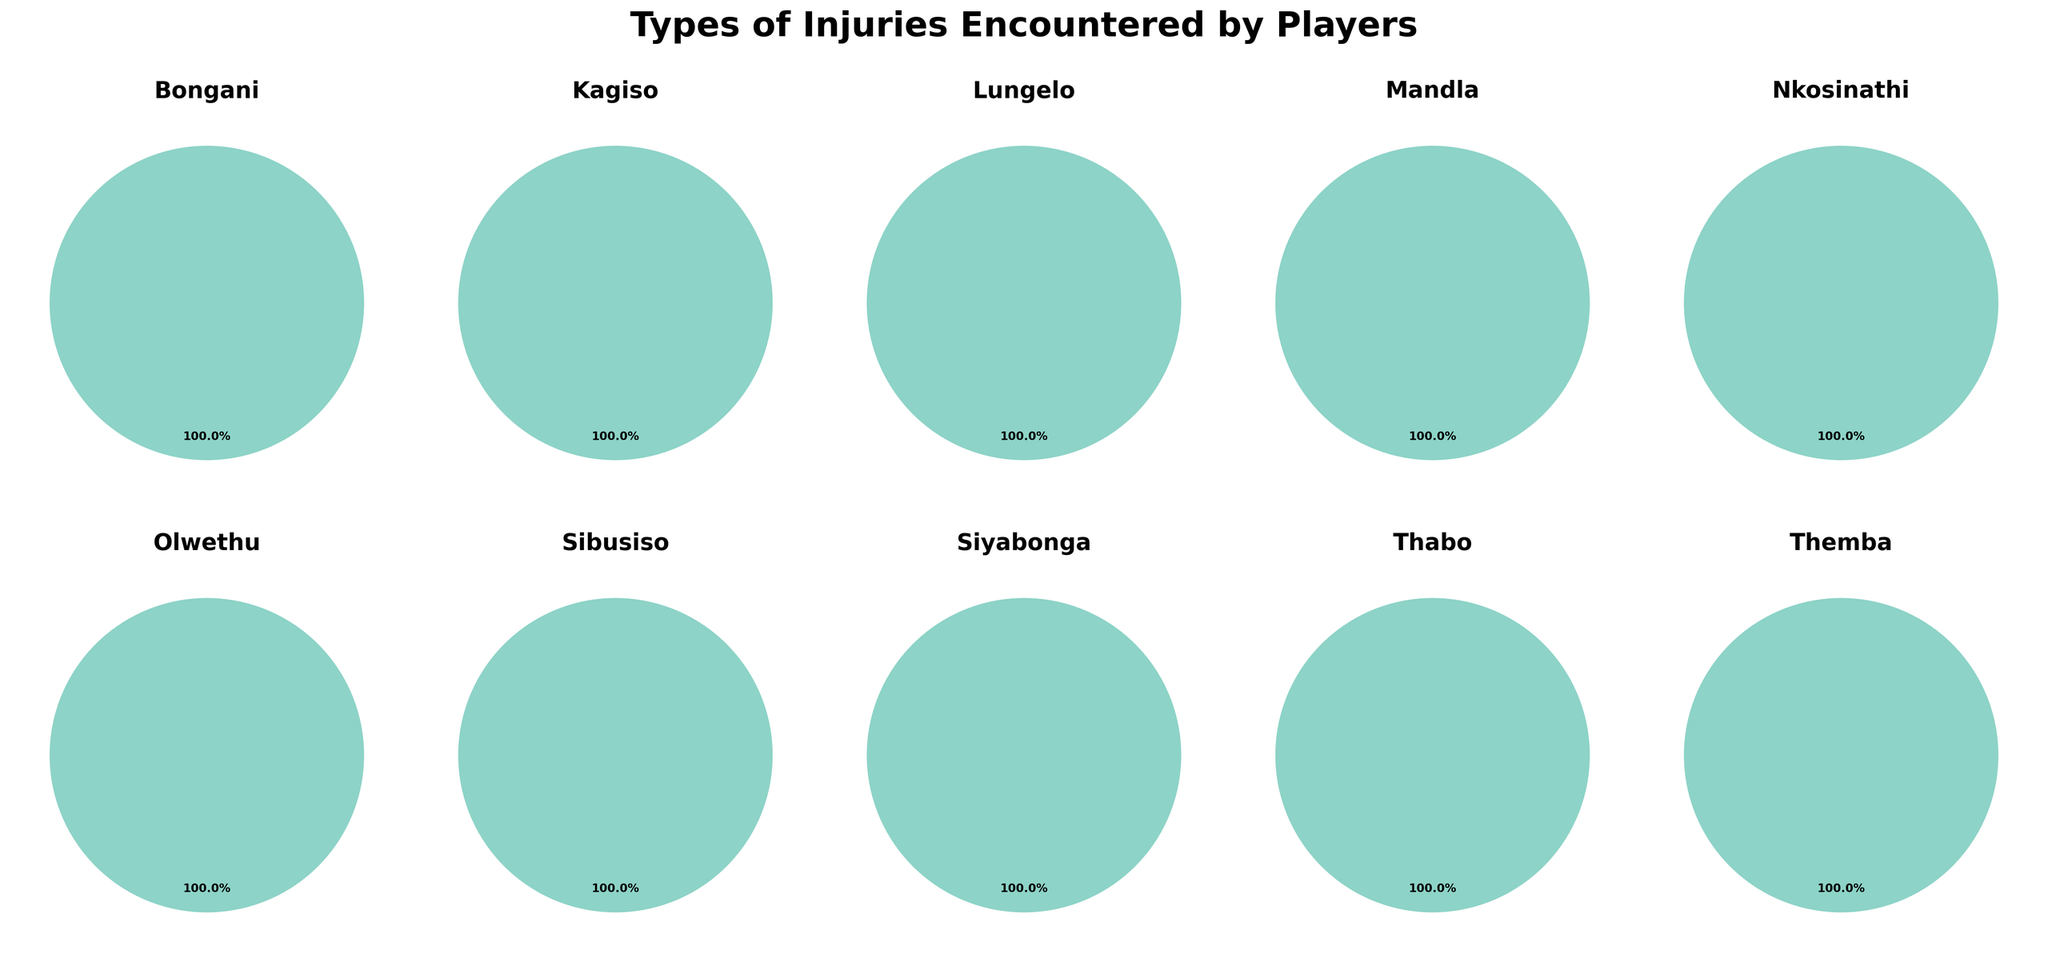What is the title of the figure? The title is placed at the top center of the figure, making it easily recognizable.
Answer: Types of Injuries Encountered by Players Which player has encountered the most injuries due to Ankle Sprain? From the pie charts, we can see the injury types for each player. Olwethu's pie chart shows Ankle Sprain as the dominant injury type.
Answer: Olwethu How many players have suffered from Groin Strain? We look for the 'Groin Strain' category in each player's pie chart. Only Bongani has Groin Strain in his chart.
Answer: 1 Which player has the highest percentage of Calf Strain injuries? We can identify the percentage of Calf Strain injuries from the pie charts where the 'Calf Strain' wedge is colored. Lungelo's pie chart shows a significant portion of Calf Strain injuries.
Answer: Lungelo Compare the number of injuries between Calf Strain and Achilles Tendinitis. Which one is more common? By summing up the injury counts for each type, Calf Strain (Lungelo: 6) vs. Achilles Tendinitis (Sibusiso: 2).
Answer: Calf Strain Who has the least number of injuries overall? By comparing the total number of injuries across all the pie charts, Themba has the lowest with only 1 injury.
Answer: Themba What is the combined percentage of Hamstring Strain and Concussion injuries for all players? We sum the Hamstring Strain (Thabo: 5) and Concussion (Siyabonga: 2) counts and divide by the total number of injuries across all players before converting to a percentage.
Answer: 7/(7+5+3+4+2+6+1+3+4+2) * 100 ≈ 17.1% How many players have over 4 injury incidents? We check each pie chart for players with a total injury count greater than 4 (Olwethu, Thabo, Lungelo).
Answer: 3 Which players have knee-related injuries, and how do their counts compare? Identify players with knee-related injuries (Mandla has Knee Ligament Tear: 3, and Kagiso has Shin Splints: 3). The counts are equal as both players have the same number of knee-related injuries.
Answer: Mandla and Kagiso have 3 each 